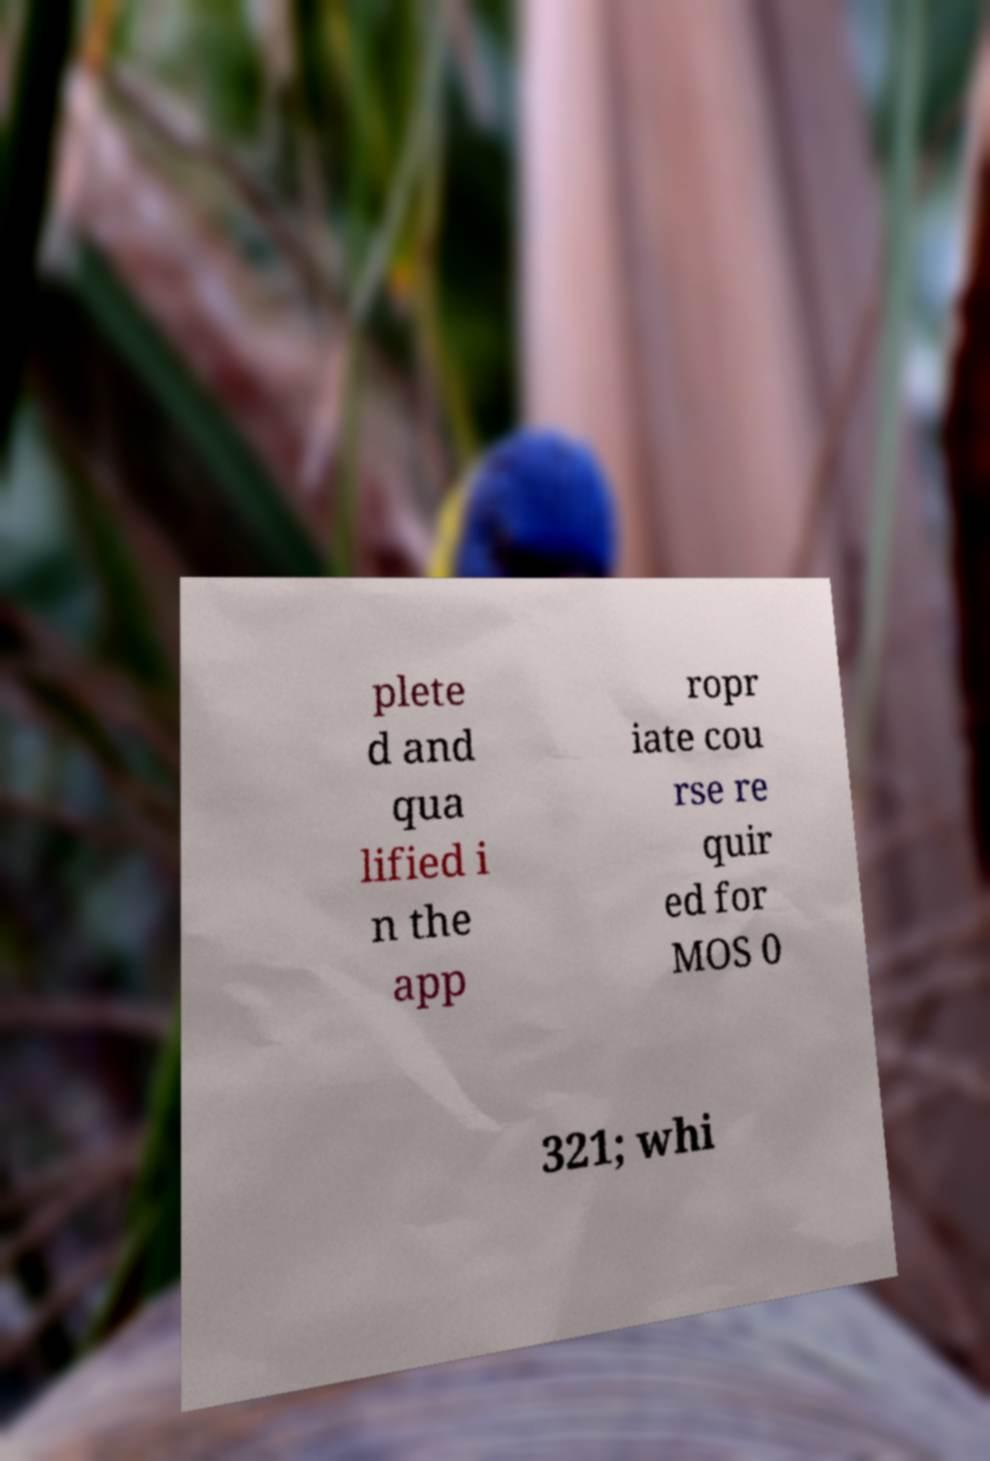What messages or text are displayed in this image? I need them in a readable, typed format. plete d and qua lified i n the app ropr iate cou rse re quir ed for MOS 0 321; whi 